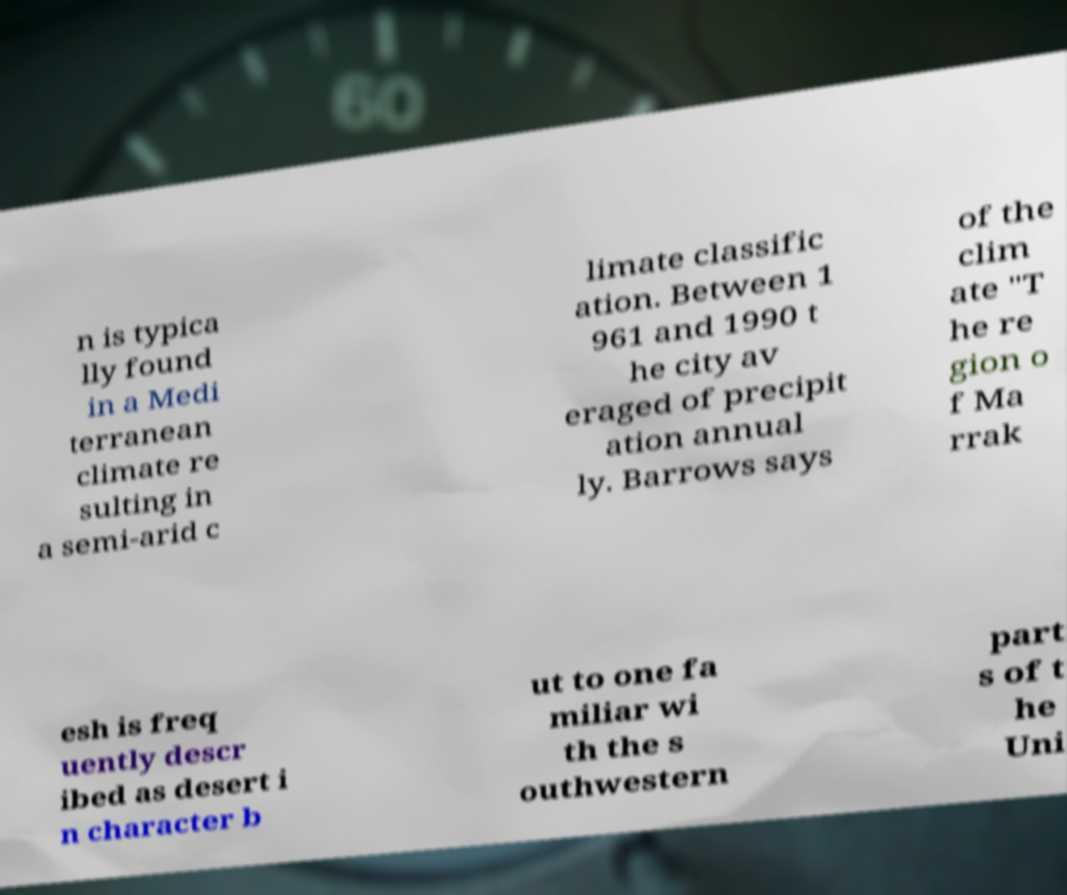Can you accurately transcribe the text from the provided image for me? n is typica lly found in a Medi terranean climate re sulting in a semi-arid c limate classific ation. Between 1 961 and 1990 t he city av eraged of precipit ation annual ly. Barrows says of the clim ate "T he re gion o f Ma rrak esh is freq uently descr ibed as desert i n character b ut to one fa miliar wi th the s outhwestern part s of t he Uni 